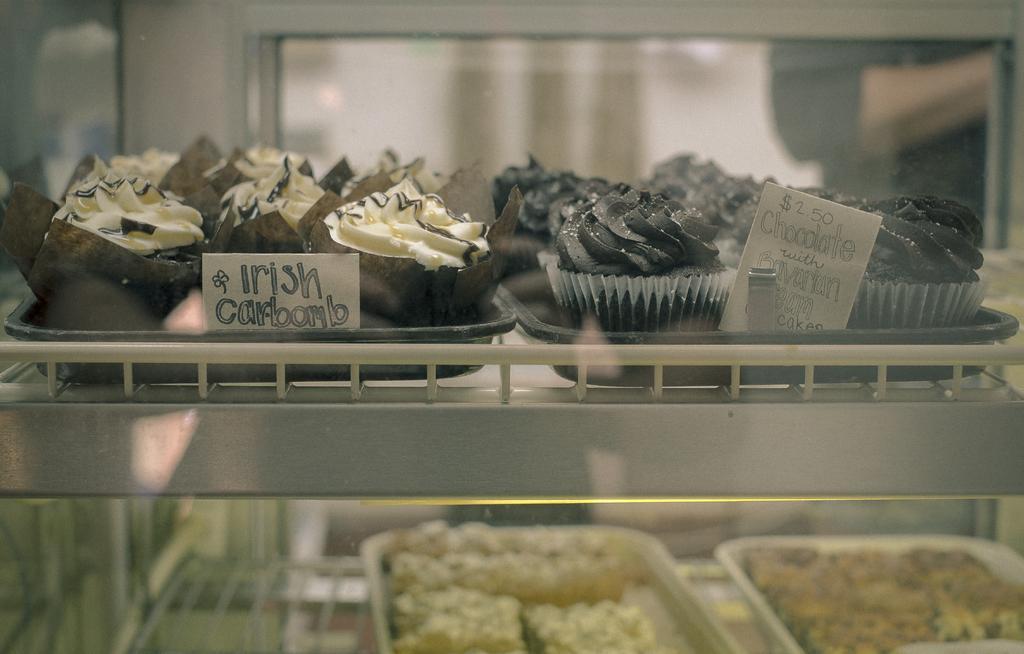How would you summarize this image in a sentence or two? In this image we can see cupcakes and desserts places in the shelves and there are trays. 